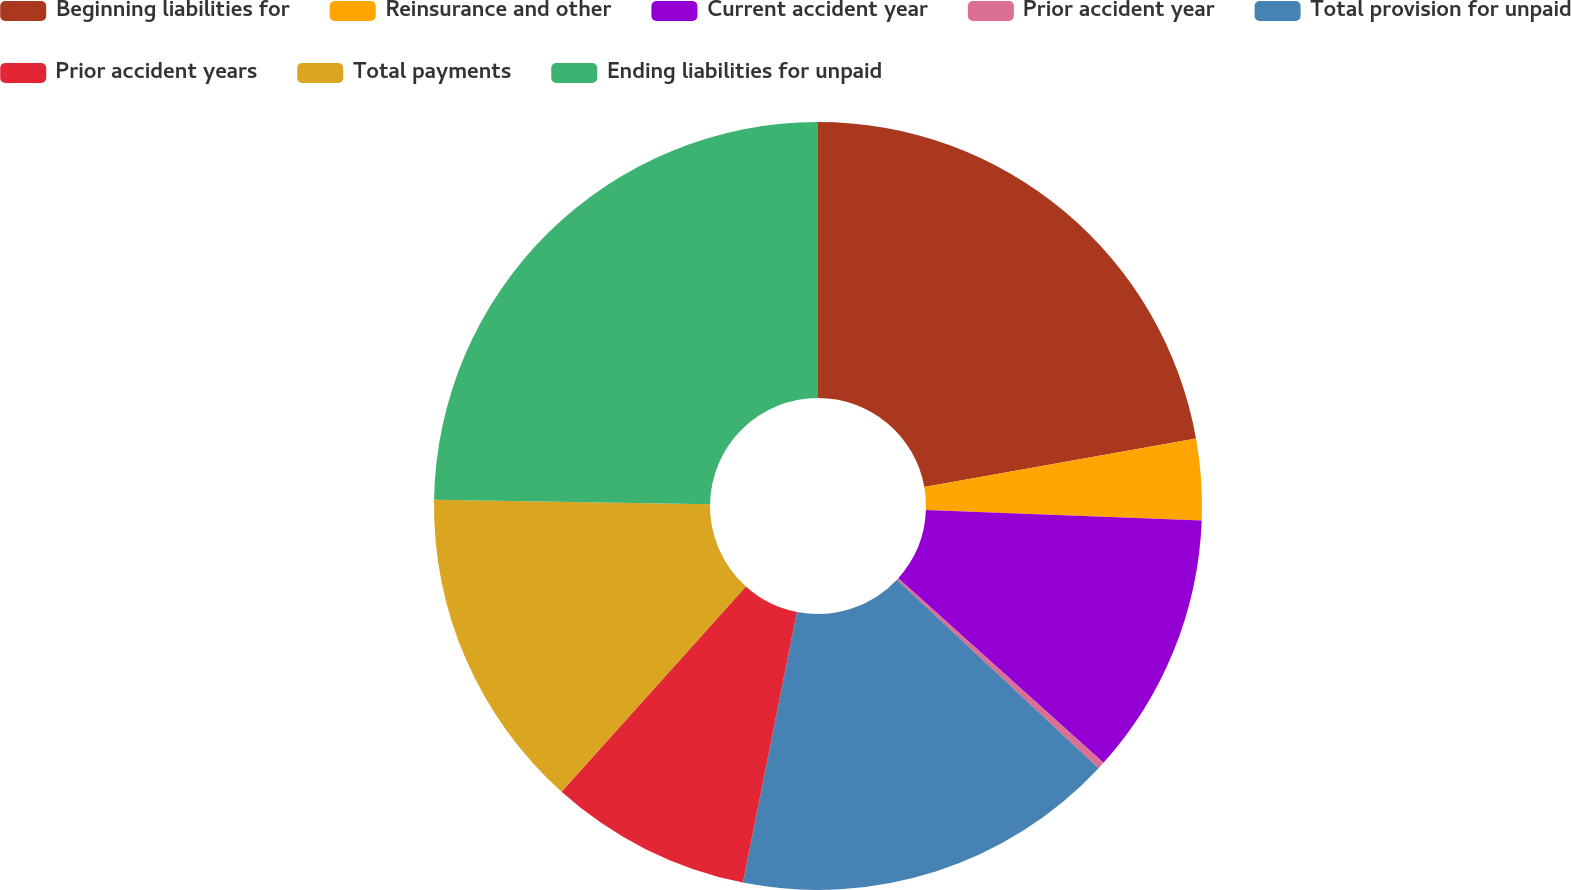Convert chart. <chart><loc_0><loc_0><loc_500><loc_500><pie_chart><fcel>Beginning liabilities for<fcel>Reinsurance and other<fcel>Current accident year<fcel>Prior accident year<fcel>Total provision for unpaid<fcel>Prior accident years<fcel>Total payments<fcel>Ending liabilities for unpaid<nl><fcel>22.19%<fcel>3.41%<fcel>11.06%<fcel>0.3%<fcel>16.17%<fcel>8.51%<fcel>13.62%<fcel>24.74%<nl></chart> 